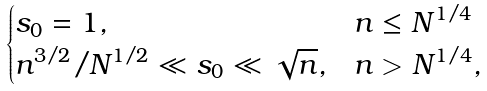<formula> <loc_0><loc_0><loc_500><loc_500>\begin{cases} s _ { 0 } = 1 , & n \leq N ^ { 1 / 4 } \\ n ^ { 3 / 2 } / N ^ { 1 / 2 } \ll s _ { 0 } \ll \sqrt { n } , & n > N ^ { 1 / 4 } , \end{cases}</formula> 